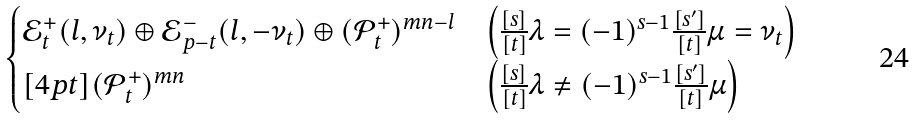Convert formula to latex. <formula><loc_0><loc_0><loc_500><loc_500>\begin{cases} \mathcal { E } _ { t } ^ { + } ( l , \nu _ { t } ) \oplus \mathcal { E } _ { p - t } ^ { - } ( l , - \nu _ { t } ) \oplus ( \mathcal { P } _ { t } ^ { + } ) ^ { m n - l } & \left ( \frac { [ s ] } { [ t ] } \lambda = ( - 1 ) ^ { s - 1 } \frac { [ s ^ { \prime } ] } { [ t ] } \mu = \nu _ { t } \right ) \\ [ 4 p t ] ( \mathcal { P } _ { t } ^ { + } ) ^ { m n } & \left ( \frac { [ s ] } { [ t ] } \lambda \ne ( - 1 ) ^ { s - 1 } \frac { [ s ^ { \prime } ] } { [ t ] } \mu \right ) \end{cases}</formula> 